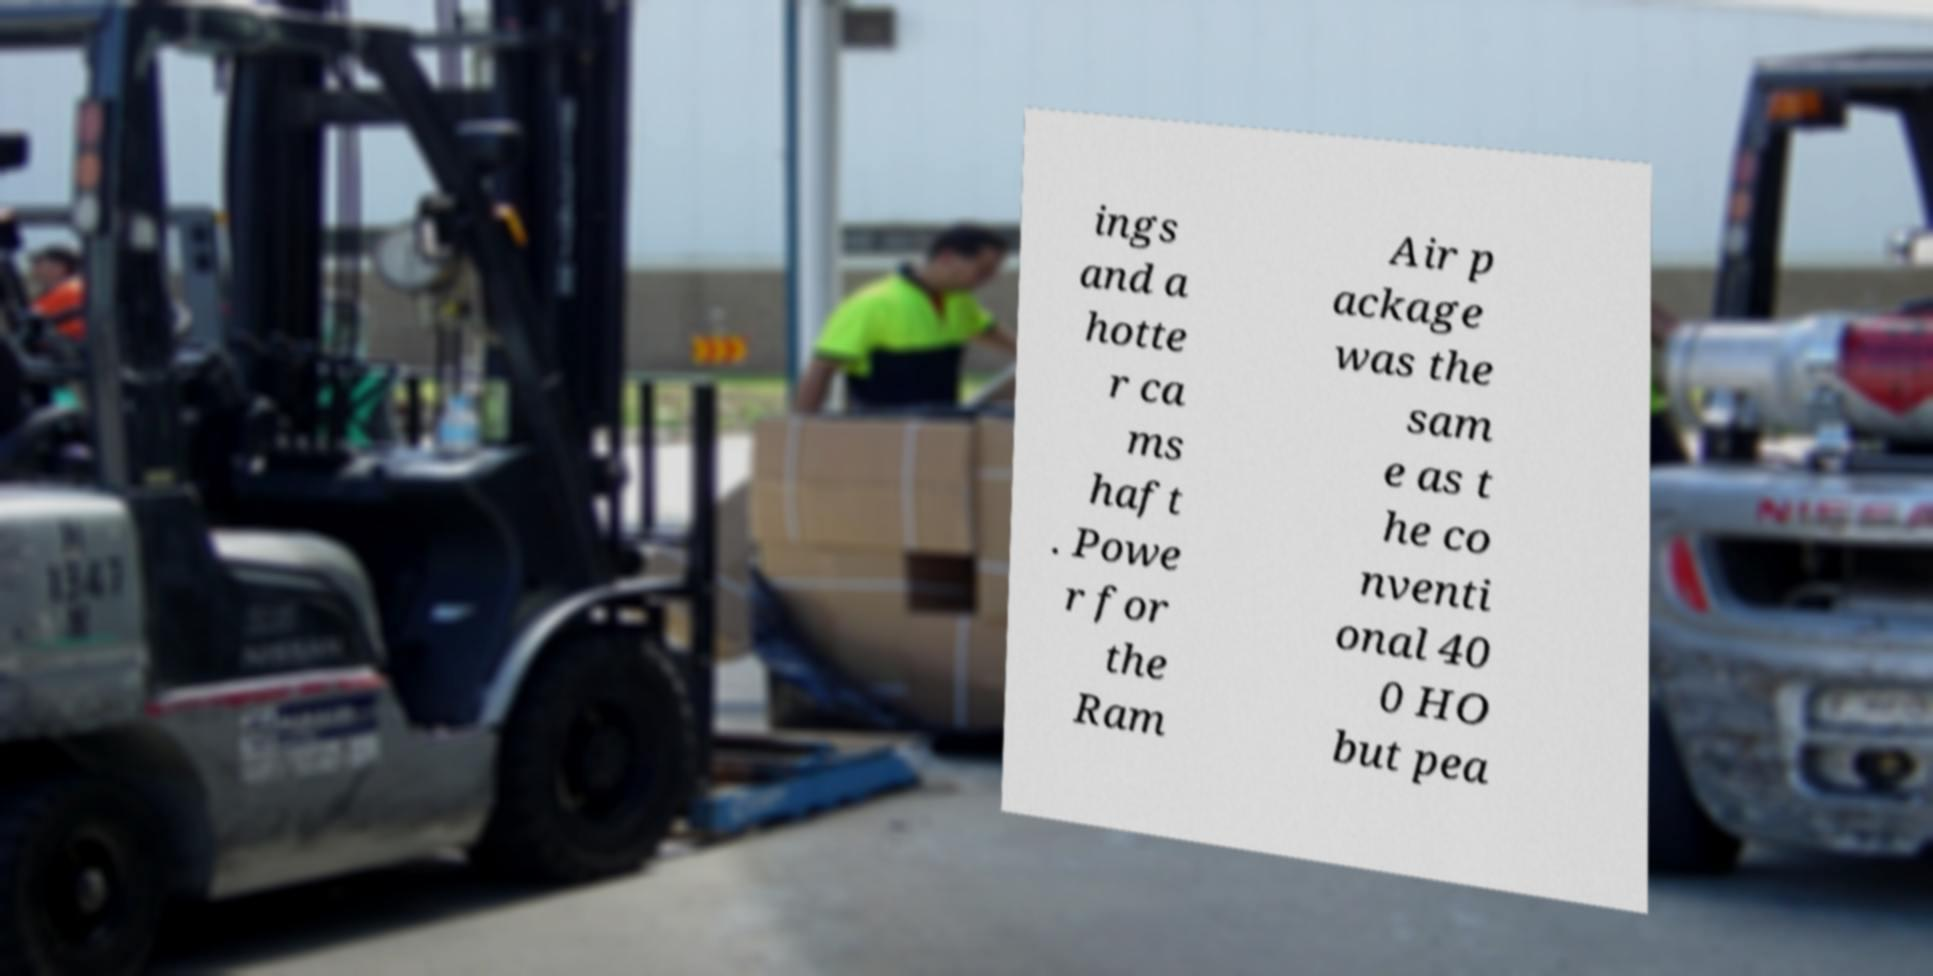There's text embedded in this image that I need extracted. Can you transcribe it verbatim? ings and a hotte r ca ms haft . Powe r for the Ram Air p ackage was the sam e as t he co nventi onal 40 0 HO but pea 